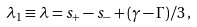<formula> <loc_0><loc_0><loc_500><loc_500>\lambda _ { 1 } \equiv \lambda = s _ { + } - s _ { - } + ( \gamma - \Gamma ) / 3 \, ,</formula> 